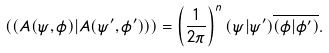<formula> <loc_0><loc_0><loc_500><loc_500>\left ( \left ( A ( \psi , \phi ) | A ( \psi ^ { \prime } , \phi ^ { \prime } ) \right ) \right ) = \left ( \frac { 1 } { 2 \pi } \right ) ^ { n } ( \psi | \psi ^ { \prime } ) \overline { ( \phi | \phi ^ { \prime } ) } .</formula> 